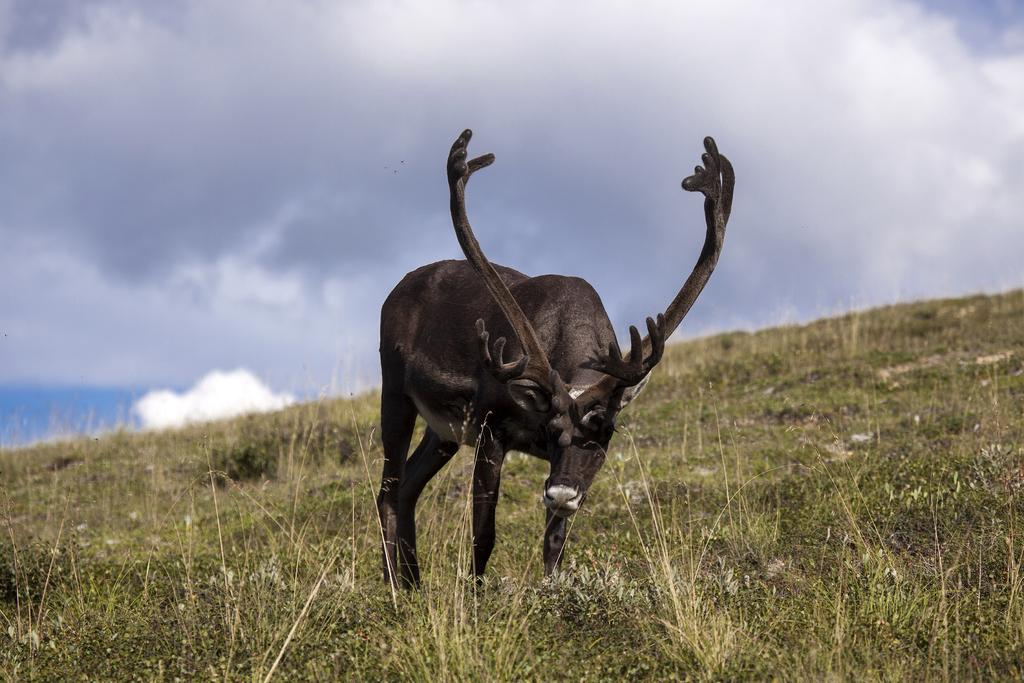What animal is the main subject of the picture? There is a reindeer in the picture. Where is the reindeer located in the image? The reindeer is standing on a mountain cliff. What type of vegetation can be seen on the ground in the picture? There is grass on the ground in the picture. What is the condition of the sky in the image? The sky is clear in the picture. What type of lace can be seen on the reindeer's antlers in the image? There is no lace present on the reindeer's antlers in the image. What territory does the reindeer claim as its own in the image? The image does not depict the reindeer claiming any territory. 